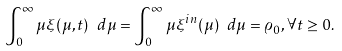<formula> <loc_0><loc_0><loc_500><loc_500>\int _ { 0 } ^ { \infty } \mu \xi ( \mu , t ) \ d \mu = \int _ { 0 } ^ { \infty } \mu \xi ^ { i n } ( \mu ) \ d \mu = \varrho _ { 0 } , \forall t \geq 0 .</formula> 